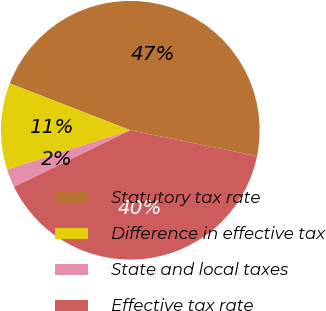Convert chart. <chart><loc_0><loc_0><loc_500><loc_500><pie_chart><fcel>Statutory tax rate<fcel>Difference in effective tax<fcel>State and local taxes<fcel>Effective tax rate<nl><fcel>47.3%<fcel>10.81%<fcel>2.3%<fcel>39.59%<nl></chart> 